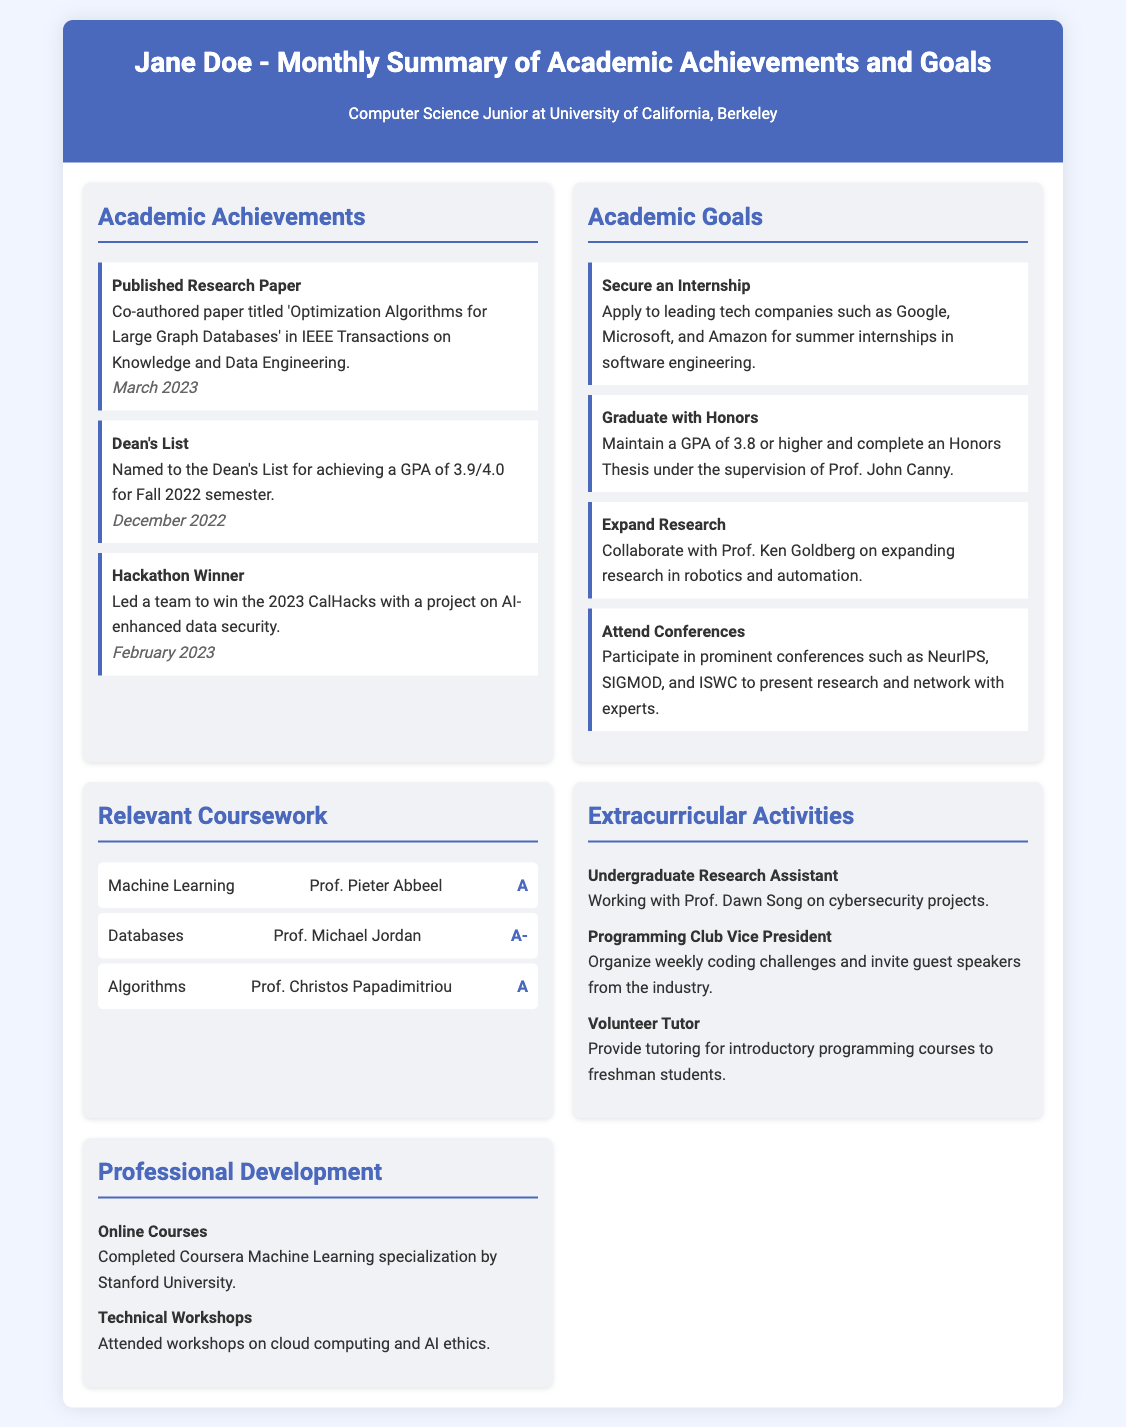what is the title of the published research paper? The title of the published research paper is mentioned in the achievements section where it states 'Optimization Algorithms for Large Graph Databases'.
Answer: Optimization Algorithms for Large Graph Databases who is the Dean for the semester mentioned in the Dean's List achievement? The Dean's List achievement does not explicitly mention a Dean, but it highlights the student's academic performance.
Answer: Not mentioned what GPA did Jane achieve to be on the Dean's List? The document states that Jane achieved a GPA of 3.9/4.0 to be named on the Dean's List.
Answer: 3.9/4.0 which professor is Jane collaborating with for her research goals? The document indicates that Jane aims to collaborate with Prof. Ken Goldberg on expanding research in robotics and automation.
Answer: Prof. Ken Goldberg how many academic goals are listed in the document? The document outlines four specific academic goals for Jane, as listed in the goals section.
Answer: 4 what is one of the extracurricular activities Jane is involved in? The document includes several extracurricular activities; one example is her role as an Undergraduate Research Assistant.
Answer: Undergraduate Research Assistant what was Jane's grade in the course Algorithms? The coursework section specifies that Jane received an 'A' grade in the Algorithms course.
Answer: A when was the Hackathon event Jane participated in? The event date can be found under academic achievements, where it states that the Hackathon occurred in February 2023.
Answer: February 2023 which online course did Jane complete? The document mentions that Jane completed the Coursera Machine Learning specialization by Stanford University as part of her professional development.
Answer: Coursera Machine Learning specialization 